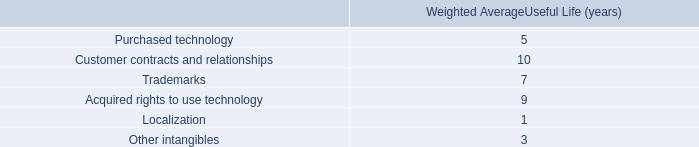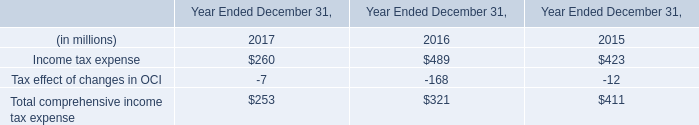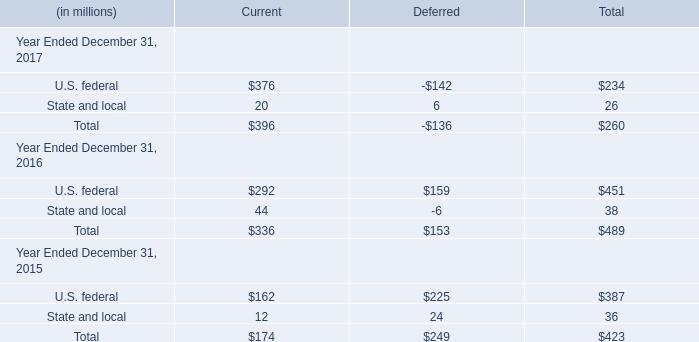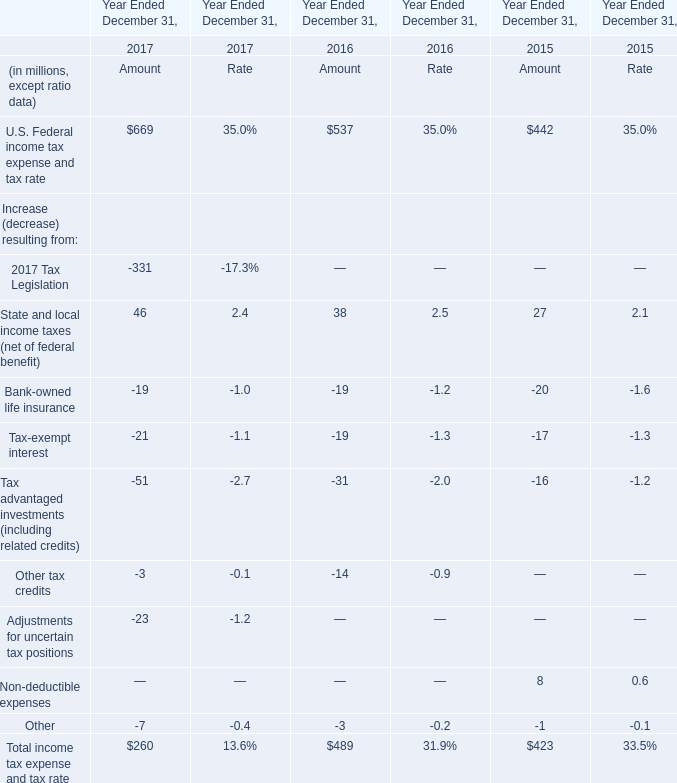In which year the U.S. Federal income tax expense and tax rate is positive? 
Answer: 2017. 